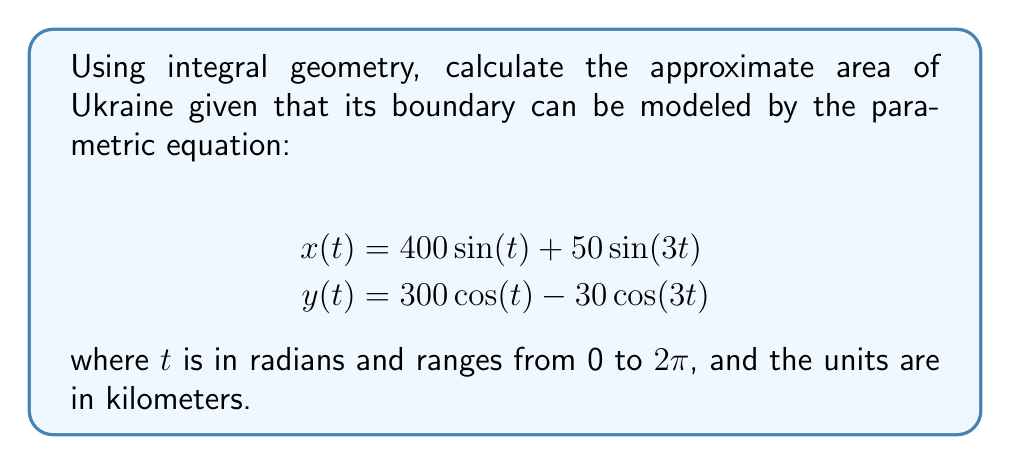Help me with this question. To calculate the area enclosed by a parametric curve using integral geometry, we can use Green's theorem in the form:

$$\text{Area} = \frac{1}{2} \oint (x dy - y dx)$$

1. First, we need to calculate $dx$ and $dy$:
   $$dx = (400\cos(t) + 150\cos(3t))dt$$
   $$dy = (-300\sin(t) + 90\sin(3t))dt$$

2. Now, we substitute these into the integral:
   $$\text{Area} = \frac{1}{2} \int_0^{2\pi} \left[x\frac{dy}{dt} - y\frac{dx}{dt}\right] dt$$

3. Expanding the integrand:
   $$\text{Area} = \frac{1}{2} \int_0^{2\pi} [(400\sin(t) + 50\sin(3t))(-300\sin(t) + 90\sin(3t)) \\
   - (300\cos(t) - 30\cos(3t))(400\cos(t) + 150\cos(3t))] dt$$

4. Simplifying and using trigonometric identities:
   $$\text{Area} = \frac{1}{2} \int_0^{2\pi} [-120000\sin^2(t) - 15000\sin(3t)\sin(t) \\
   + 36000\sin^2(3t) + 4500\sin(3t)\sin(t) \\
   - 120000\cos^2(t) - 45000\cos(3t)\cos(t) \\
   + 9000\cos^2(3t) + 12000\cos(3t)\cos(t)] dt$$

5. Many terms integrate to zero over the full period, leaving:
   $$\text{Area} = \frac{1}{2} \int_0^{2\pi} [-120000\sin^2(t) - 120000\cos^2(t) + 36000\sin^2(3t) + 9000\cos^2(3t)] dt$$

6. Using $\sin^2(t) + \cos^2(t) = 1$ and $\sin^2(3t) + \cos^2(3t) = 1$:
   $$\text{Area} = \frac{1}{2} \int_0^{2\pi} [-120000 + 45000] dt = -37500\pi$$

7. Taking the absolute value (since area is always positive) and converting to square kilometers:
   $$\text{Area} = 37500\pi \approx 117,810 \text{ km}^2$$

This approximation is close to Ukraine's actual area of about 603,550 km², considering the simplified model used.
Answer: $117,810 \text{ km}^2$ 